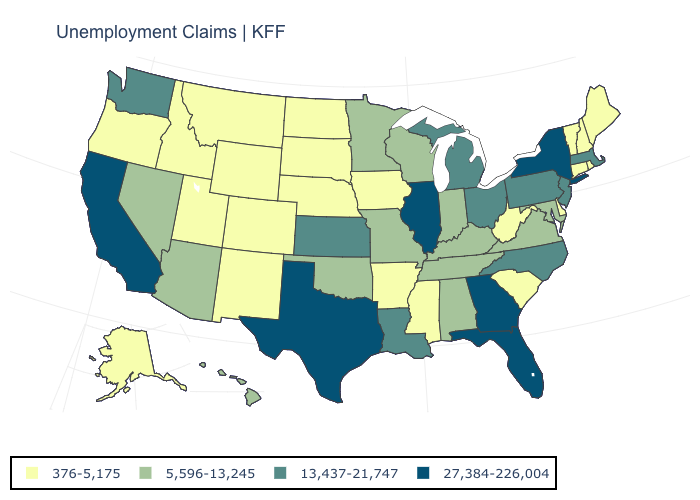Name the states that have a value in the range 5,596-13,245?
Be succinct. Alabama, Arizona, Hawaii, Indiana, Kentucky, Maryland, Minnesota, Missouri, Nevada, Oklahoma, Tennessee, Virginia, Wisconsin. What is the value of New Hampshire?
Keep it brief. 376-5,175. What is the value of Delaware?
Keep it brief. 376-5,175. What is the value of Colorado?
Answer briefly. 376-5,175. What is the highest value in the USA?
Give a very brief answer. 27,384-226,004. Name the states that have a value in the range 376-5,175?
Keep it brief. Alaska, Arkansas, Colorado, Connecticut, Delaware, Idaho, Iowa, Maine, Mississippi, Montana, Nebraska, New Hampshire, New Mexico, North Dakota, Oregon, Rhode Island, South Carolina, South Dakota, Utah, Vermont, West Virginia, Wyoming. What is the lowest value in states that border Wisconsin?
Quick response, please. 376-5,175. What is the lowest value in states that border Massachusetts?
Be succinct. 376-5,175. What is the value of Wyoming?
Write a very short answer. 376-5,175. Does Massachusetts have a lower value than Maryland?
Short answer required. No. What is the value of Missouri?
Answer briefly. 5,596-13,245. Name the states that have a value in the range 27,384-226,004?
Concise answer only. California, Florida, Georgia, Illinois, New York, Texas. Which states have the highest value in the USA?
Write a very short answer. California, Florida, Georgia, Illinois, New York, Texas. Name the states that have a value in the range 5,596-13,245?
Write a very short answer. Alabama, Arizona, Hawaii, Indiana, Kentucky, Maryland, Minnesota, Missouri, Nevada, Oklahoma, Tennessee, Virginia, Wisconsin. Which states have the highest value in the USA?
Give a very brief answer. California, Florida, Georgia, Illinois, New York, Texas. 